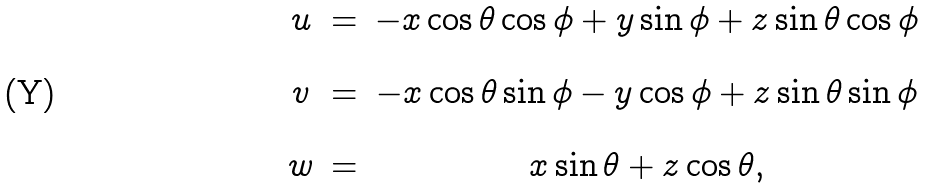Convert formula to latex. <formula><loc_0><loc_0><loc_500><loc_500>\begin{array} { c c c } u & = & - x \cos \theta \cos \phi + y \sin \phi + z \sin \theta \cos \phi \\ \\ v & = & - x \cos \theta \sin \phi - y \cos \phi + z \sin \theta \sin \phi \\ \\ w & = & x \sin \theta + z \cos \theta , \end{array}</formula> 